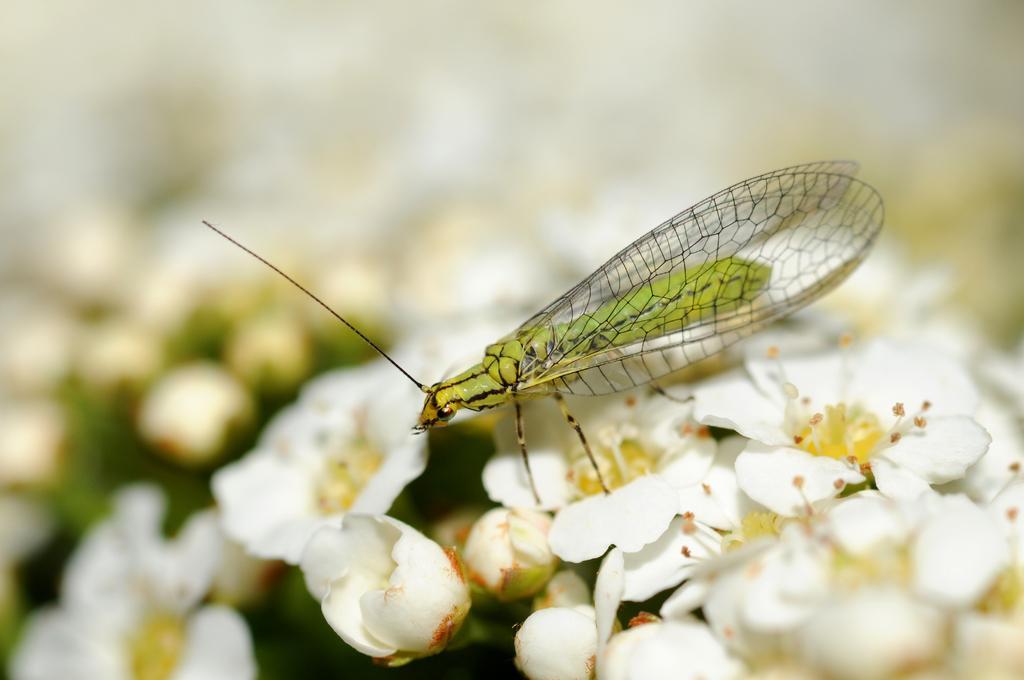Could you give a brief overview of what you see in this image? In this image there is an insect on the flowers. 